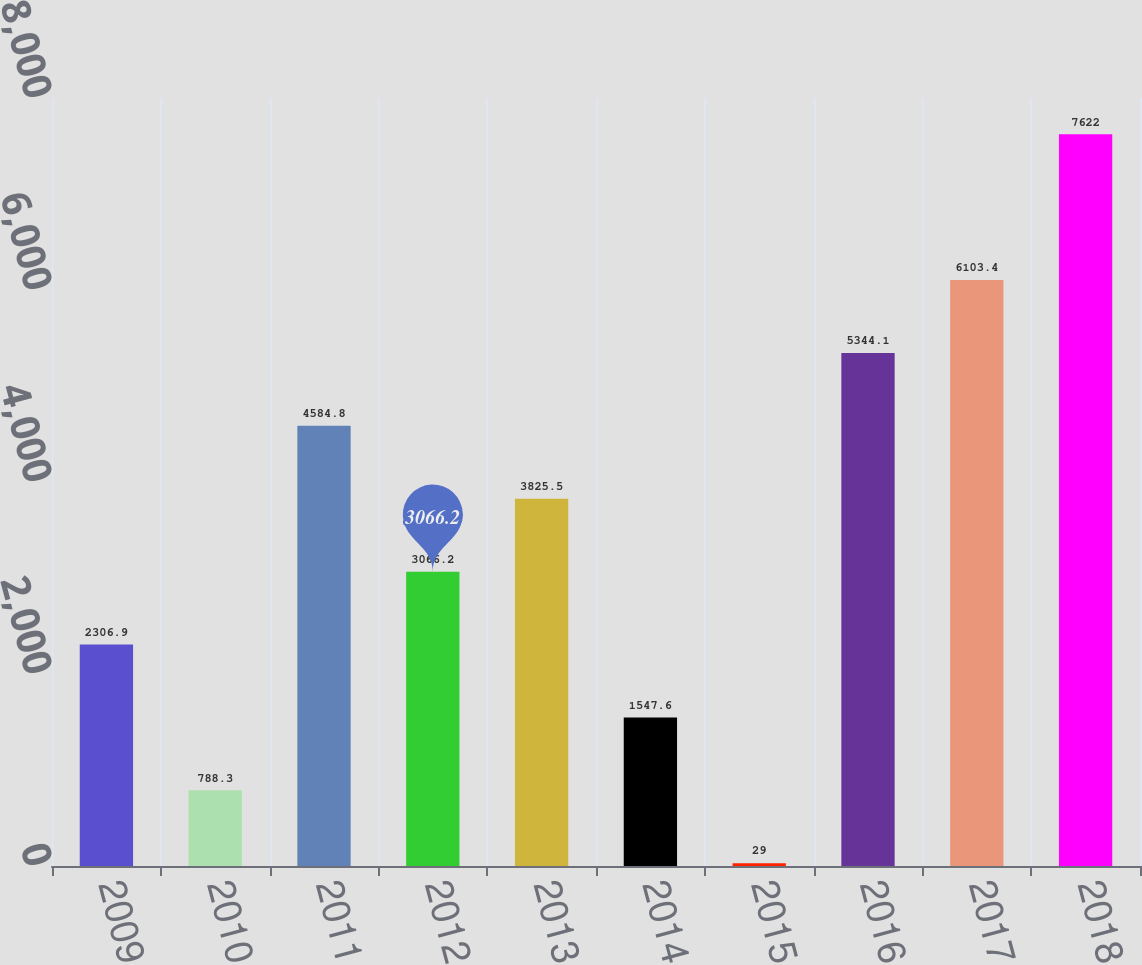Convert chart. <chart><loc_0><loc_0><loc_500><loc_500><bar_chart><fcel>2009<fcel>2010<fcel>2011<fcel>2012<fcel>2013<fcel>2014<fcel>2015<fcel>2016<fcel>2017<fcel>2018<nl><fcel>2306.9<fcel>788.3<fcel>4584.8<fcel>3066.2<fcel>3825.5<fcel>1547.6<fcel>29<fcel>5344.1<fcel>6103.4<fcel>7622<nl></chart> 